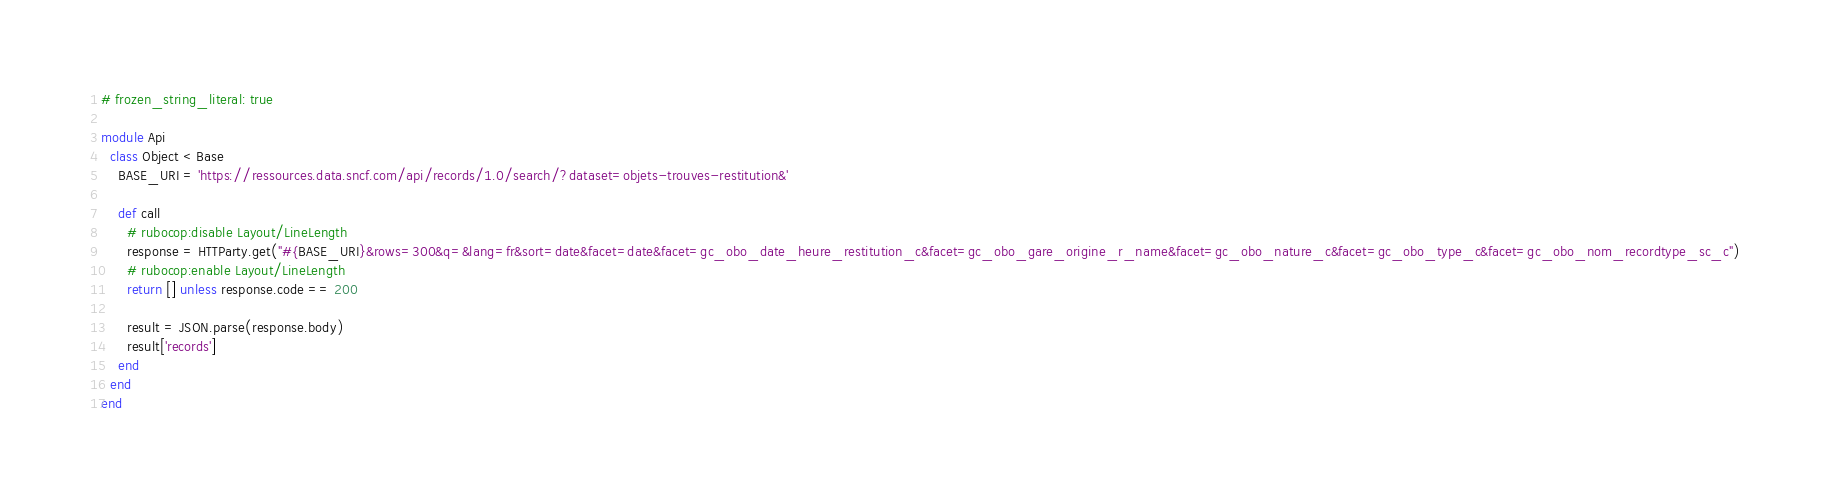Convert code to text. <code><loc_0><loc_0><loc_500><loc_500><_Ruby_># frozen_string_literal: true

module Api
  class Object < Base
    BASE_URI = 'https://ressources.data.sncf.com/api/records/1.0/search/?dataset=objets-trouves-restitution&'

    def call
      # rubocop:disable Layout/LineLength
      response = HTTParty.get("#{BASE_URI}&rows=300&q=&lang=fr&sort=date&facet=date&facet=gc_obo_date_heure_restitution_c&facet=gc_obo_gare_origine_r_name&facet=gc_obo_nature_c&facet=gc_obo_type_c&facet=gc_obo_nom_recordtype_sc_c")
      # rubocop:enable Layout/LineLength
      return [] unless response.code == 200

      result = JSON.parse(response.body)
      result['records']
    end
  end
end
</code> 